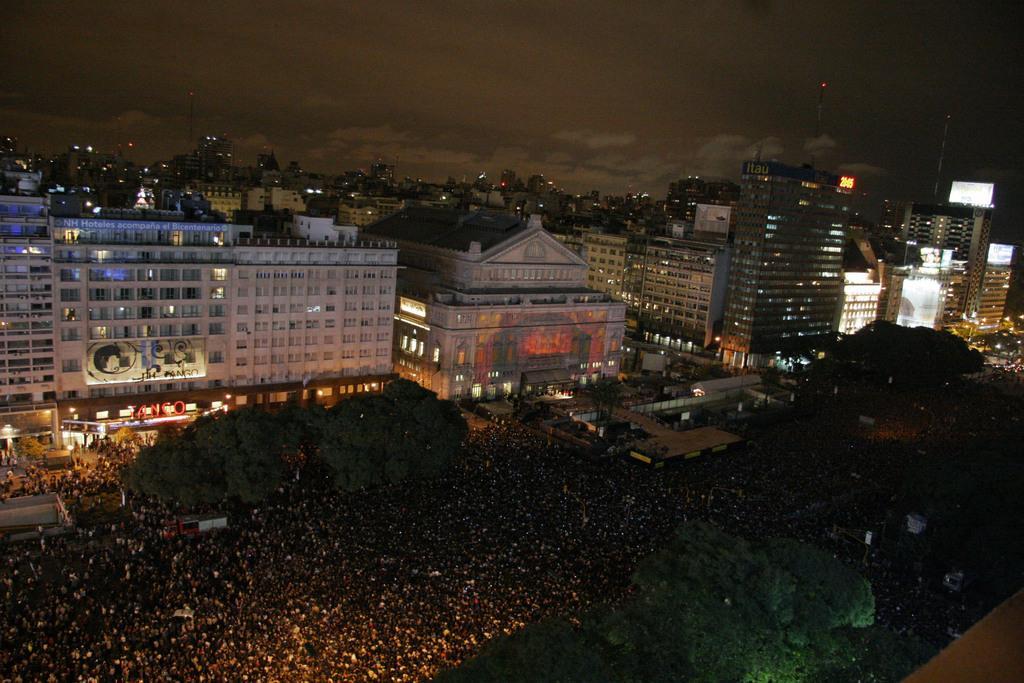How would you summarize this image in a sentence or two? In this image we can see there are buildings with lights, in front of the building we can see there are a few people on the ground and there are trees. At the top we can see the sky. 